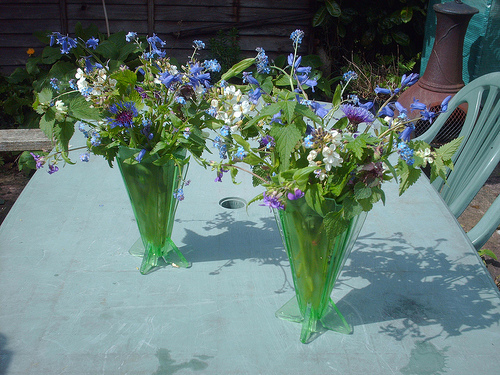Please provide the bounding box coordinate of the region this sentence describes: blue outdoor chair by a table. The coordinates [0.81, 0.26, 0.99, 0.62] accurately outline the area occupied by a blue, slatted, plastic chair placed adjacent to an outdoor table. 